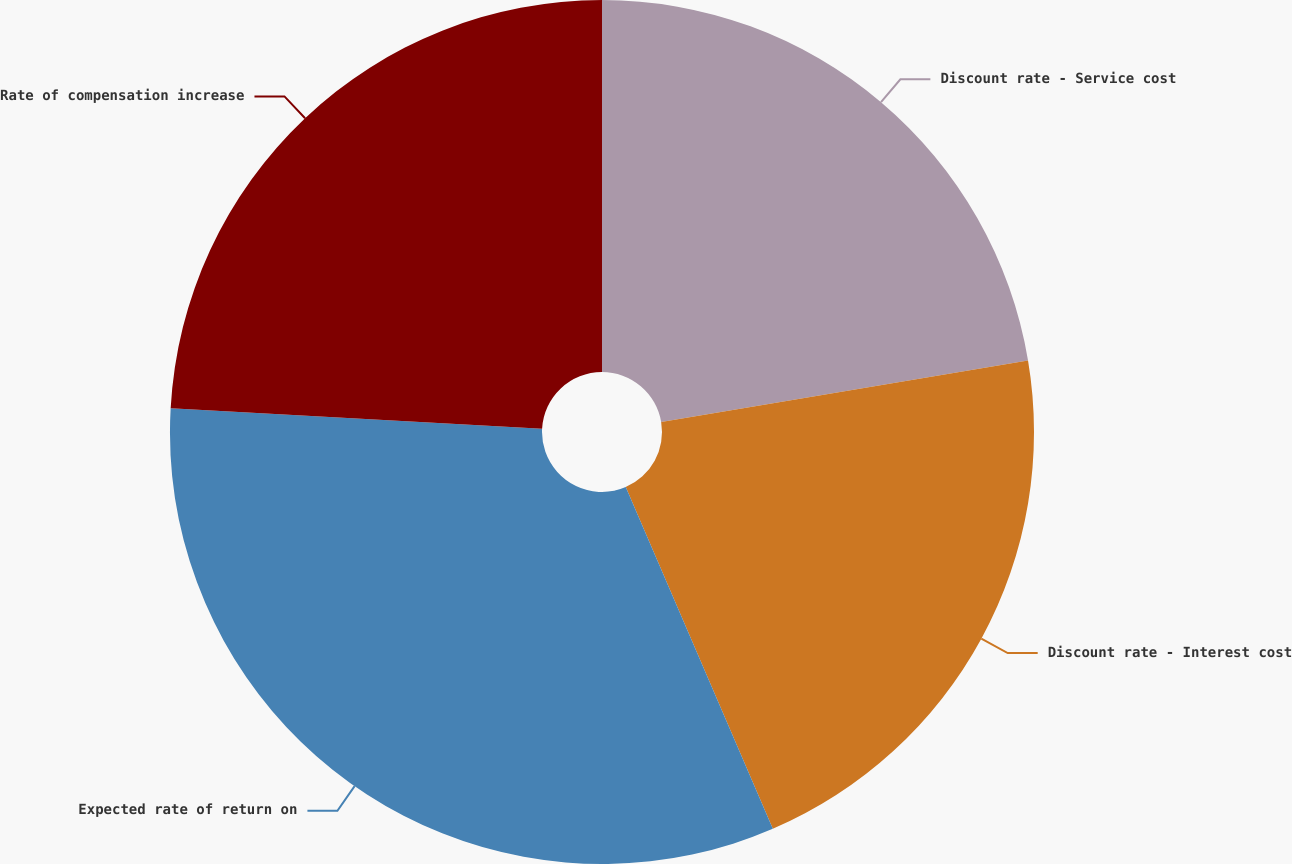<chart> <loc_0><loc_0><loc_500><loc_500><pie_chart><fcel>Discount rate - Service cost<fcel>Discount rate - Interest cost<fcel>Expected rate of return on<fcel>Rate of compensation increase<nl><fcel>22.35%<fcel>21.18%<fcel>32.35%<fcel>24.12%<nl></chart> 